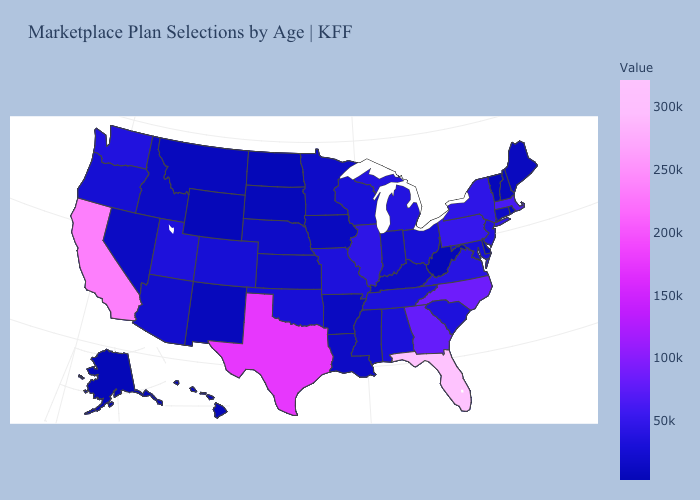Among the states that border Vermont , which have the highest value?
Answer briefly. Massachusetts. Which states have the highest value in the USA?
Write a very short answer. Florida. Does Louisiana have a lower value than Texas?
Write a very short answer. Yes. Is the legend a continuous bar?
Quick response, please. Yes. Does Texas have a lower value than Louisiana?
Keep it brief. No. Which states have the highest value in the USA?
Keep it brief. Florida. Which states hav the highest value in the West?
Keep it brief. California. Does West Virginia have the lowest value in the USA?
Short answer required. Yes. 